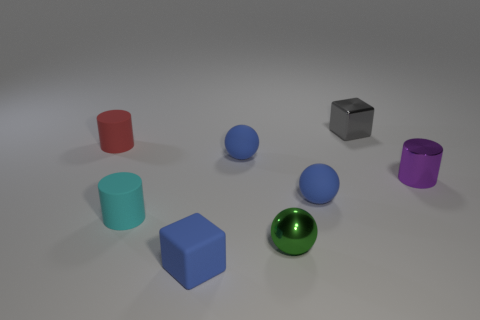Add 1 tiny objects. How many objects exist? 9 Subtract all cylinders. How many objects are left? 5 Subtract 0 green cylinders. How many objects are left? 8 Subtract all small purple metallic things. Subtract all big green matte cubes. How many objects are left? 7 Add 7 green metal things. How many green metal things are left? 8 Add 3 purple shiny objects. How many purple shiny objects exist? 4 